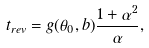Convert formula to latex. <formula><loc_0><loc_0><loc_500><loc_500>t _ { r e v } = g ( \theta _ { 0 } , b ) \frac { 1 + \alpha ^ { 2 } } { \alpha } ,</formula> 